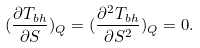Convert formula to latex. <formula><loc_0><loc_0><loc_500><loc_500>( \frac { \partial T _ { b h } } { \partial S } ) _ { Q } = ( \frac { \partial ^ { 2 } T _ { b h } } { \partial S ^ { 2 } } ) _ { Q } = 0 .</formula> 